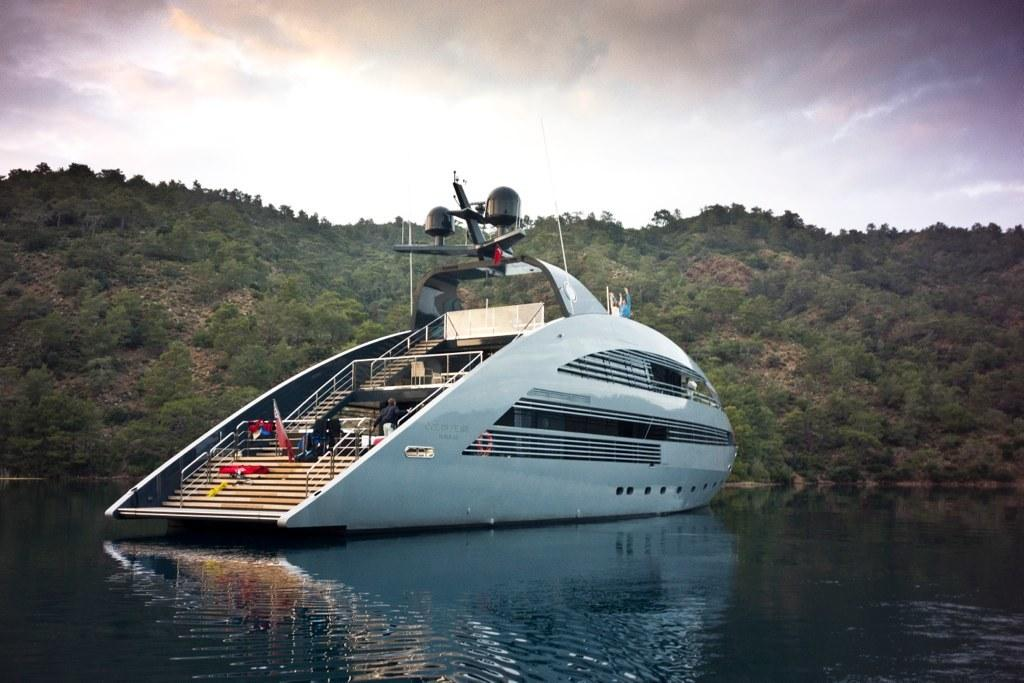What is the main subject of the image? The main subject of the image is a ship. Where is the ship located? The ship is on the water. Can you describe the person on the ship? There is a man in the ship. What can be seen in the background of the image? There are trees and clouds in the background of the image. What type of butter is being used to control the ship in the image? There is no butter present in the image, and the ship is not being controlled by any butter. 